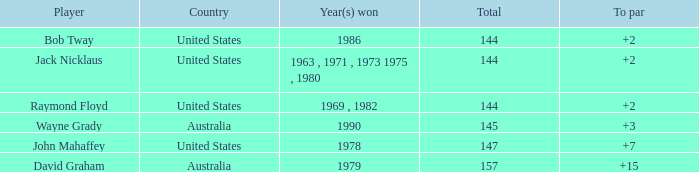What was the average round score of the player who won in 1978? 147.0. 